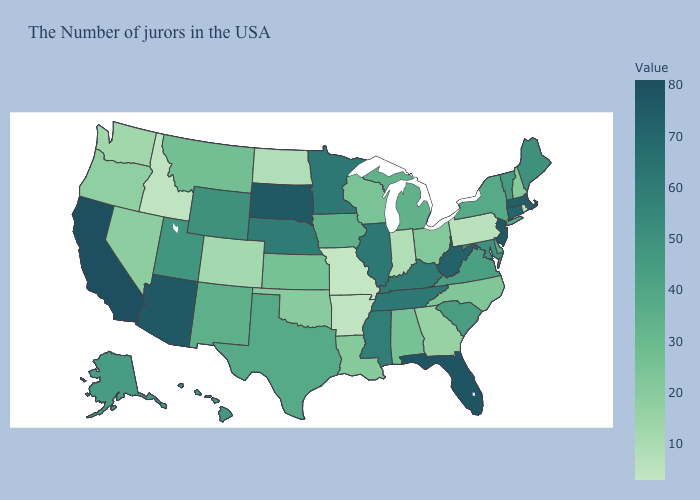Which states have the lowest value in the MidWest?
Give a very brief answer. Missouri. Among the states that border Delaware , does New Jersey have the highest value?
Give a very brief answer. Yes. Among the states that border Massachusetts , does Connecticut have the highest value?
Answer briefly. Yes. Which states have the highest value in the USA?
Quick response, please. California. Does Arizona have the lowest value in the West?
Answer briefly. No. Which states have the highest value in the USA?
Give a very brief answer. California. Does Missouri have the lowest value in the MidWest?
Concise answer only. Yes. 